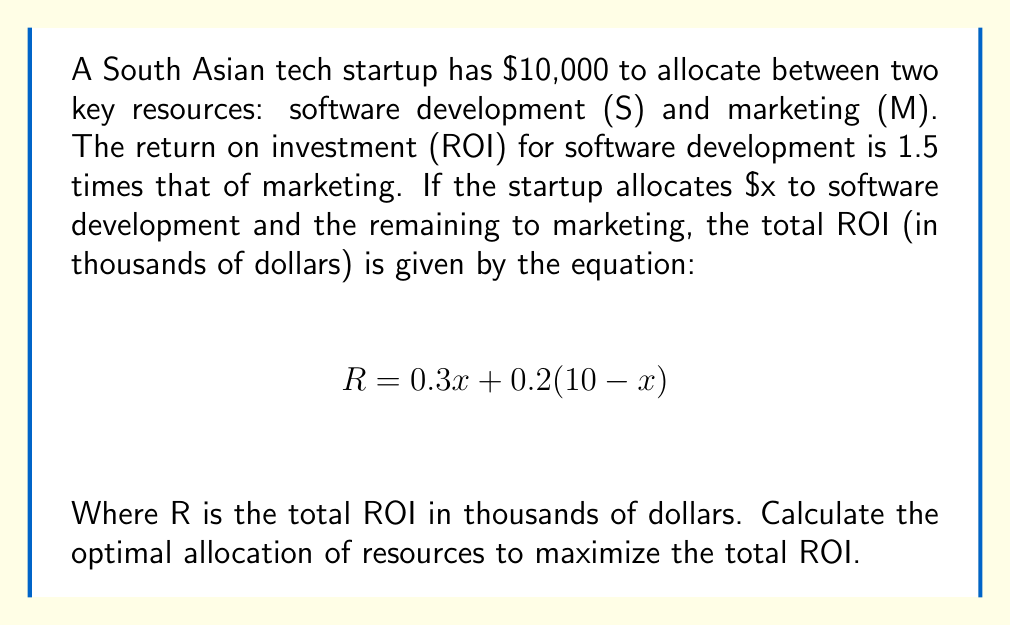Provide a solution to this math problem. To solve this problem, we need to follow these steps:

1) First, let's understand the equation:
   $$ R = 0.3x + 0.2(10 - x) $$
   Here, x represents the amount (in thousands) allocated to software development, and (10 - x) represents the amount allocated to marketing.

2) To find the maximum ROI, we need to differentiate R with respect to x and set it to zero:
   $$ \frac{dR}{dx} = 0.3 - 0.2 = 0.1 $$

3) The derivative is a constant (0.1), which means the function is linear and always increasing with respect to x. This implies that the maximum ROI will be achieved when we allocate the maximum possible amount to software development.

4) Given that the ROI for software development is 1.5 times that of marketing, we can confirm this mathematically:
   $$ \frac{0.3}{0.2} = 1.5 $$

5) Therefore, the optimal allocation is to invest all $10,000 into software development.

6) To calculate the maximum ROI:
   $$ R = 0.3(10) + 0.2(0) = 3 $$

Thus, the maximum ROI is $3,000.
Answer: The optimal allocation is $10,000 to software development and $0 to marketing, resulting in a maximum ROI of $3,000. 